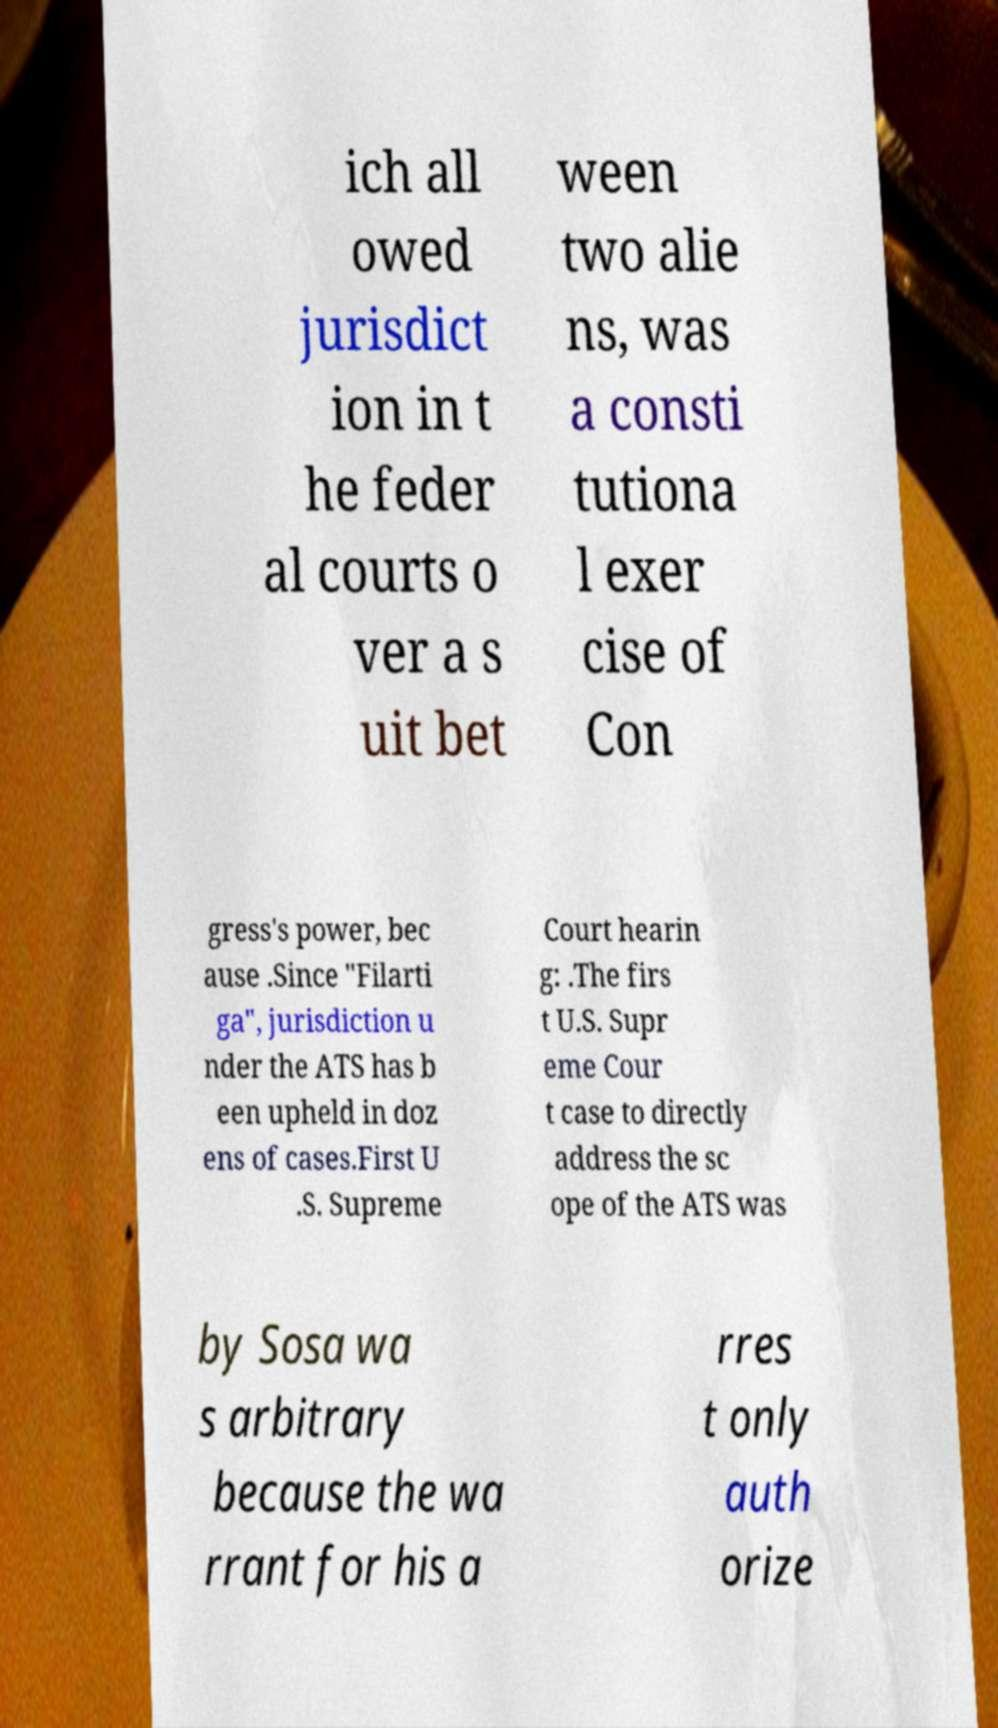Please identify and transcribe the text found in this image. ich all owed jurisdict ion in t he feder al courts o ver a s uit bet ween two alie ns, was a consti tutiona l exer cise of Con gress's power, bec ause .Since "Filarti ga", jurisdiction u nder the ATS has b een upheld in doz ens of cases.First U .S. Supreme Court hearin g: .The firs t U.S. Supr eme Cour t case to directly address the sc ope of the ATS was by Sosa wa s arbitrary because the wa rrant for his a rres t only auth orize 